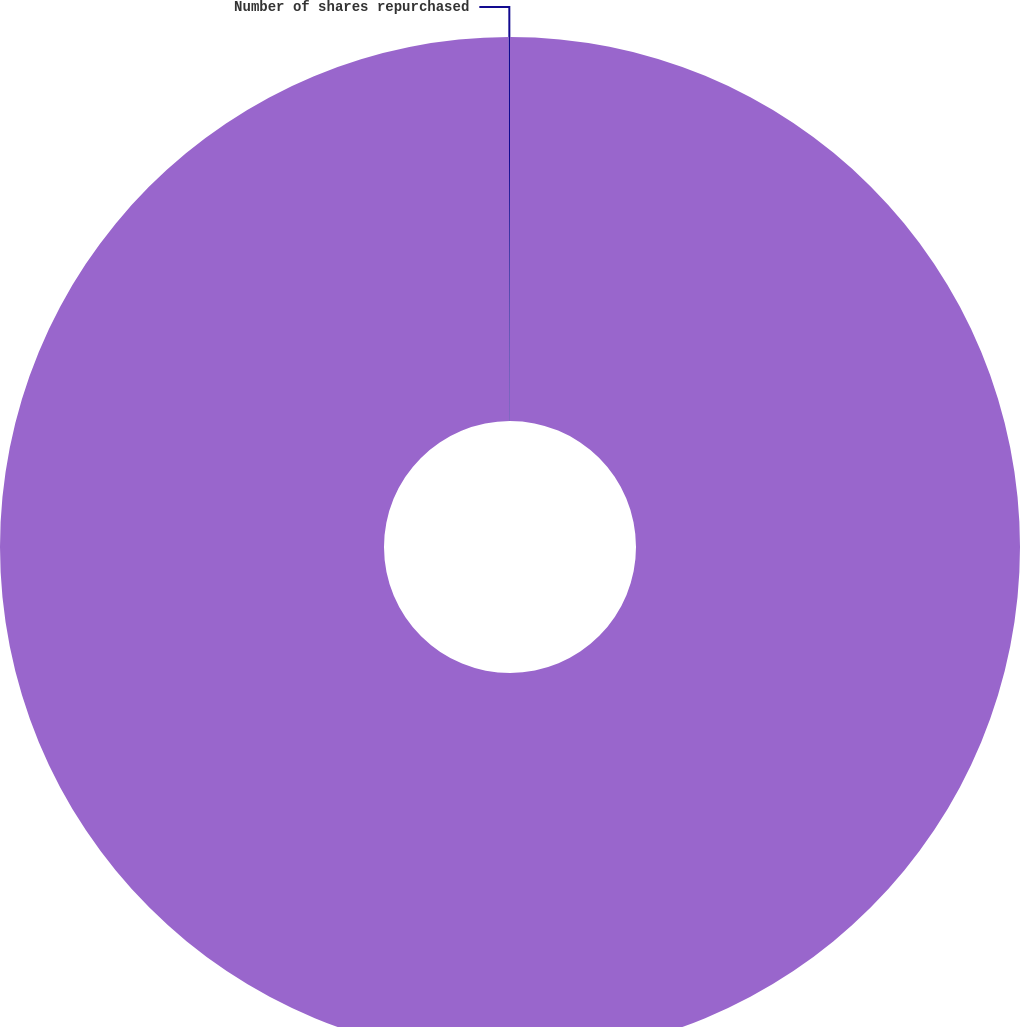<chart> <loc_0><loc_0><loc_500><loc_500><pie_chart><fcel>Aggregate purchase price<fcel>Number of shares repurchased<nl><fcel>99.96%<fcel>0.04%<nl></chart> 